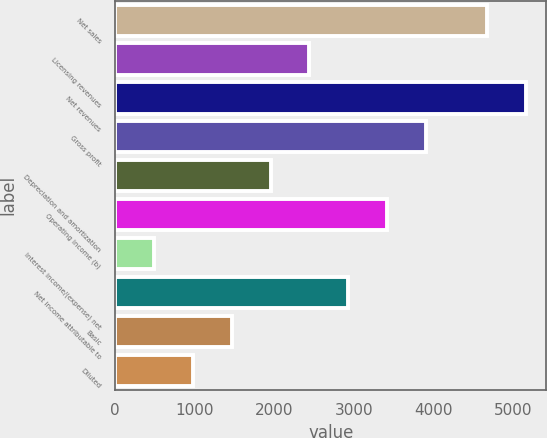Convert chart to OTSL. <chart><loc_0><loc_0><loc_500><loc_500><bar_chart><fcel>Net sales<fcel>Licensing revenues<fcel>Net revenues<fcel>Gross profit<fcel>Depreciation and amortization<fcel>Operating income (b)<fcel>Interest income/(expense) net<fcel>Net income attributable to<fcel>Basic<fcel>Diluted<nl><fcel>4670.7<fcel>2440.15<fcel>5158.69<fcel>3904.12<fcel>1952.16<fcel>3416.13<fcel>488.19<fcel>2928.14<fcel>1464.17<fcel>976.18<nl></chart> 